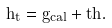Convert formula to latex. <formula><loc_0><loc_0><loc_500><loc_500>h _ { t } = { g _ { c a l } } + t h .</formula> 